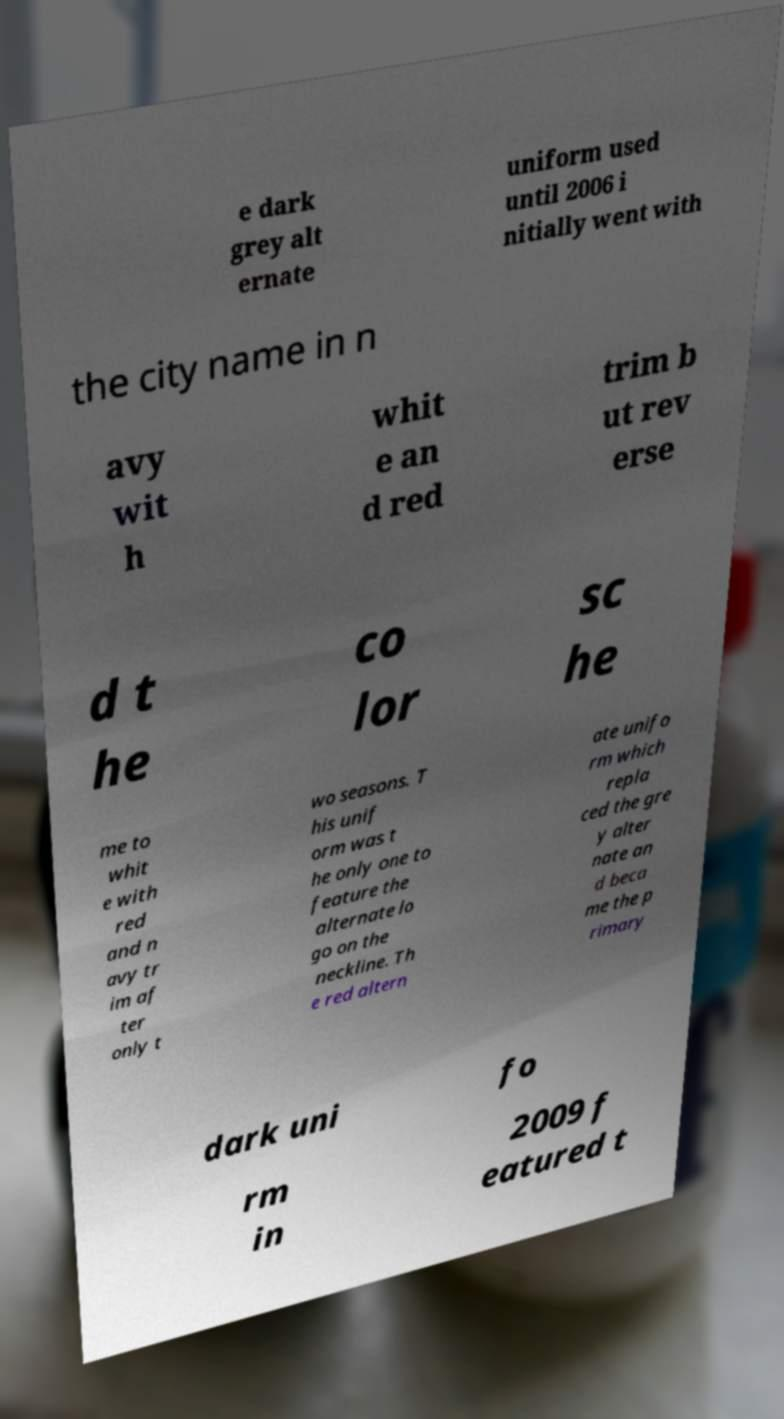Please read and relay the text visible in this image. What does it say? e dark grey alt ernate uniform used until 2006 i nitially went with the city name in n avy wit h whit e an d red trim b ut rev erse d t he co lor sc he me to whit e with red and n avy tr im af ter only t wo seasons. T his unif orm was t he only one to feature the alternate lo go on the neckline. Th e red altern ate unifo rm which repla ced the gre y alter nate an d beca me the p rimary dark uni fo rm in 2009 f eatured t 